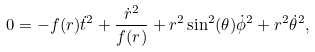<formula> <loc_0><loc_0><loc_500><loc_500>0 = - f ( r ) \dot { t } ^ { 2 } + \frac { \dot { r } ^ { 2 } } { f ( r ) } + r ^ { 2 } \sin ^ { 2 } ( \theta ) \dot { \phi } ^ { 2 } + r ^ { 2 } \dot { \theta } ^ { 2 } ,</formula> 